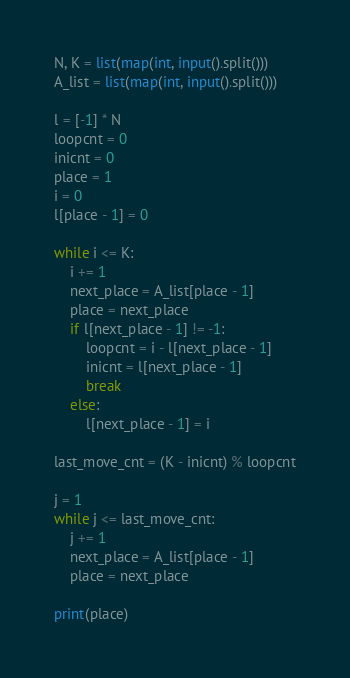<code> <loc_0><loc_0><loc_500><loc_500><_Python_>N, K = list(map(int, input().split()))
A_list = list(map(int, input().split()))

l = [-1] * N
loopcnt = 0
inicnt = 0
place = 1
i = 0
l[place - 1] = 0

while i <= K:
    i += 1
    next_place = A_list[place - 1]
    place = next_place
    if l[next_place - 1] != -1:
        loopcnt = i - l[next_place - 1]
        inicnt = l[next_place - 1]
        break
    else:
        l[next_place - 1] = i

last_move_cnt = (K - inicnt) % loopcnt

j = 1
while j <= last_move_cnt:
    j += 1
    next_place = A_list[place - 1]
    place = next_place
    
print(place)</code> 